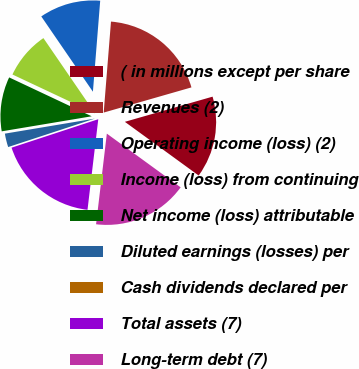Convert chart to OTSL. <chart><loc_0><loc_0><loc_500><loc_500><pie_chart><fcel>( in millions except per share<fcel>Revenues (2)<fcel>Operating income (loss) (2)<fcel>Income (loss) from continuing<fcel>Net income (loss) attributable<fcel>Diluted earnings (losses) per<fcel>Cash dividends declared per<fcel>Total assets (7)<fcel>Long-term debt (7)<nl><fcel>14.46%<fcel>19.28%<fcel>10.84%<fcel>8.43%<fcel>9.64%<fcel>2.41%<fcel>0.0%<fcel>18.07%<fcel>16.87%<nl></chart> 